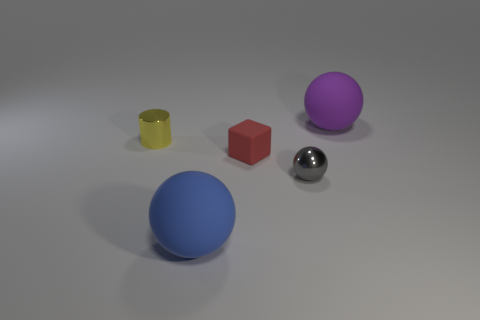Add 1 tiny metallic cylinders. How many objects exist? 6 Subtract all blocks. How many objects are left? 4 Subtract all yellow metal objects. Subtract all matte things. How many objects are left? 1 Add 1 big things. How many big things are left? 3 Add 1 small cyan matte spheres. How many small cyan matte spheres exist? 1 Subtract 0 gray blocks. How many objects are left? 5 